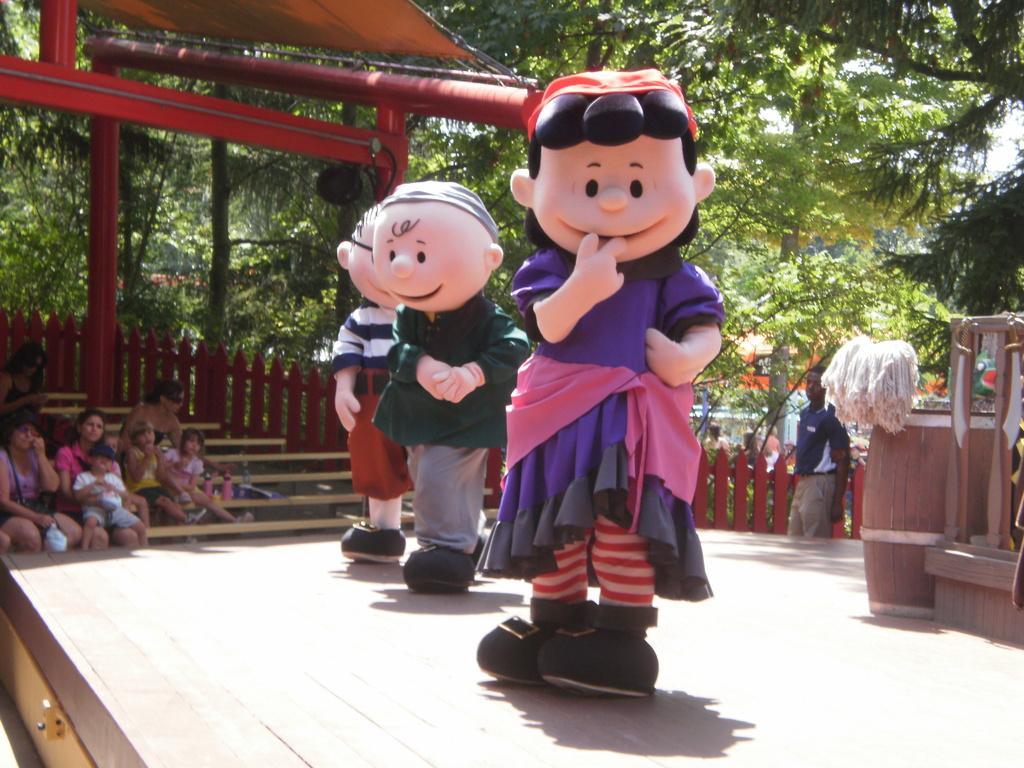How would you summarize this image in a sentence or two? Here I can see three people are wearing costumes and doing some actions on the stage. On the left side I can see few people sitting on the benches and looking at these people. In the background I can see some poles and trees. On the right side there are some wood material and a man is standing beside the fencing. 